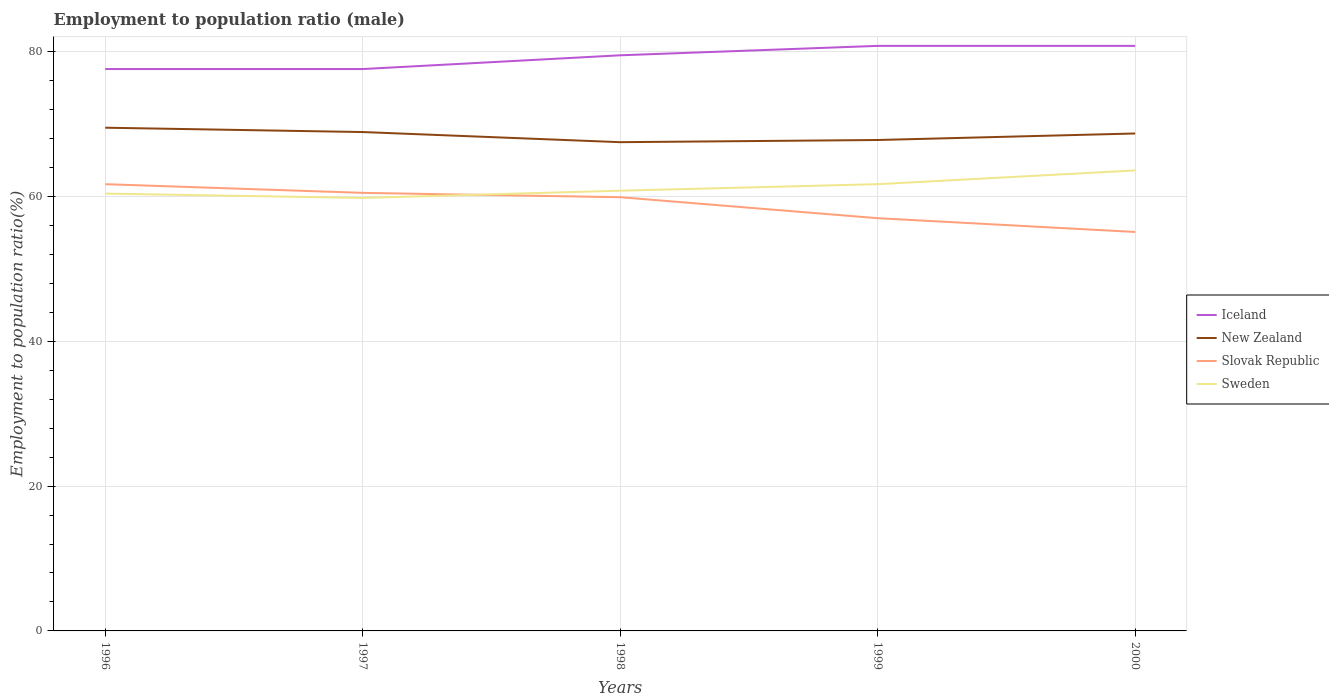Does the line corresponding to Slovak Republic intersect with the line corresponding to Sweden?
Your response must be concise. Yes. Is the number of lines equal to the number of legend labels?
Your answer should be compact. Yes. Across all years, what is the maximum employment to population ratio in Slovak Republic?
Offer a very short reply. 55.1. In which year was the employment to population ratio in Slovak Republic maximum?
Your answer should be very brief. 2000. What is the total employment to population ratio in Slovak Republic in the graph?
Provide a short and direct response. 0.6. What is the difference between the highest and the second highest employment to population ratio in Iceland?
Offer a terse response. 3.2. What is the difference between the highest and the lowest employment to population ratio in Iceland?
Offer a terse response. 3. Is the employment to population ratio in New Zealand strictly greater than the employment to population ratio in Iceland over the years?
Give a very brief answer. Yes. How many lines are there?
Provide a succinct answer. 4. How many years are there in the graph?
Offer a terse response. 5. What is the difference between two consecutive major ticks on the Y-axis?
Keep it short and to the point. 20. Does the graph contain grids?
Provide a short and direct response. Yes. Where does the legend appear in the graph?
Your answer should be very brief. Center right. How are the legend labels stacked?
Your answer should be very brief. Vertical. What is the title of the graph?
Offer a very short reply. Employment to population ratio (male). What is the Employment to population ratio(%) in Iceland in 1996?
Offer a terse response. 77.6. What is the Employment to population ratio(%) in New Zealand in 1996?
Offer a terse response. 69.5. What is the Employment to population ratio(%) in Slovak Republic in 1996?
Your answer should be very brief. 61.7. What is the Employment to population ratio(%) in Sweden in 1996?
Offer a terse response. 60.4. What is the Employment to population ratio(%) of Iceland in 1997?
Your answer should be very brief. 77.6. What is the Employment to population ratio(%) of New Zealand in 1997?
Your answer should be very brief. 68.9. What is the Employment to population ratio(%) of Slovak Republic in 1997?
Offer a very short reply. 60.5. What is the Employment to population ratio(%) in Sweden in 1997?
Ensure brevity in your answer.  59.8. What is the Employment to population ratio(%) in Iceland in 1998?
Your answer should be compact. 79.5. What is the Employment to population ratio(%) of New Zealand in 1998?
Offer a terse response. 67.5. What is the Employment to population ratio(%) of Slovak Republic in 1998?
Offer a very short reply. 59.9. What is the Employment to population ratio(%) in Sweden in 1998?
Ensure brevity in your answer.  60.8. What is the Employment to population ratio(%) of Iceland in 1999?
Your answer should be compact. 80.8. What is the Employment to population ratio(%) in New Zealand in 1999?
Keep it short and to the point. 67.8. What is the Employment to population ratio(%) of Sweden in 1999?
Provide a succinct answer. 61.7. What is the Employment to population ratio(%) of Iceland in 2000?
Your response must be concise. 80.8. What is the Employment to population ratio(%) in New Zealand in 2000?
Keep it short and to the point. 68.7. What is the Employment to population ratio(%) in Slovak Republic in 2000?
Ensure brevity in your answer.  55.1. What is the Employment to population ratio(%) of Sweden in 2000?
Keep it short and to the point. 63.6. Across all years, what is the maximum Employment to population ratio(%) in Iceland?
Provide a succinct answer. 80.8. Across all years, what is the maximum Employment to population ratio(%) in New Zealand?
Your response must be concise. 69.5. Across all years, what is the maximum Employment to population ratio(%) in Slovak Republic?
Your response must be concise. 61.7. Across all years, what is the maximum Employment to population ratio(%) of Sweden?
Your response must be concise. 63.6. Across all years, what is the minimum Employment to population ratio(%) in Iceland?
Provide a succinct answer. 77.6. Across all years, what is the minimum Employment to population ratio(%) of New Zealand?
Your answer should be very brief. 67.5. Across all years, what is the minimum Employment to population ratio(%) in Slovak Republic?
Your answer should be very brief. 55.1. Across all years, what is the minimum Employment to population ratio(%) of Sweden?
Your answer should be very brief. 59.8. What is the total Employment to population ratio(%) in Iceland in the graph?
Provide a short and direct response. 396.3. What is the total Employment to population ratio(%) of New Zealand in the graph?
Offer a very short reply. 342.4. What is the total Employment to population ratio(%) in Slovak Republic in the graph?
Your answer should be compact. 294.2. What is the total Employment to population ratio(%) of Sweden in the graph?
Offer a very short reply. 306.3. What is the difference between the Employment to population ratio(%) of Iceland in 1996 and that in 1997?
Keep it short and to the point. 0. What is the difference between the Employment to population ratio(%) of Iceland in 1996 and that in 1998?
Give a very brief answer. -1.9. What is the difference between the Employment to population ratio(%) in Slovak Republic in 1996 and that in 1998?
Your response must be concise. 1.8. What is the difference between the Employment to population ratio(%) in Iceland in 1996 and that in 1999?
Make the answer very short. -3.2. What is the difference between the Employment to population ratio(%) of Sweden in 1996 and that in 1999?
Give a very brief answer. -1.3. What is the difference between the Employment to population ratio(%) in Iceland in 1996 and that in 2000?
Your response must be concise. -3.2. What is the difference between the Employment to population ratio(%) of Sweden in 1997 and that in 1998?
Your answer should be compact. -1. What is the difference between the Employment to population ratio(%) of Iceland in 1997 and that in 1999?
Ensure brevity in your answer.  -3.2. What is the difference between the Employment to population ratio(%) in Sweden in 1997 and that in 1999?
Make the answer very short. -1.9. What is the difference between the Employment to population ratio(%) of Iceland in 1997 and that in 2000?
Give a very brief answer. -3.2. What is the difference between the Employment to population ratio(%) in New Zealand in 1997 and that in 2000?
Keep it short and to the point. 0.2. What is the difference between the Employment to population ratio(%) of Slovak Republic in 1997 and that in 2000?
Your answer should be compact. 5.4. What is the difference between the Employment to population ratio(%) of Iceland in 1998 and that in 1999?
Provide a succinct answer. -1.3. What is the difference between the Employment to population ratio(%) of New Zealand in 1998 and that in 1999?
Your answer should be very brief. -0.3. What is the difference between the Employment to population ratio(%) of Slovak Republic in 1998 and that in 1999?
Your answer should be compact. 2.9. What is the difference between the Employment to population ratio(%) of Iceland in 1998 and that in 2000?
Offer a very short reply. -1.3. What is the difference between the Employment to population ratio(%) of Iceland in 1999 and that in 2000?
Keep it short and to the point. 0. What is the difference between the Employment to population ratio(%) in New Zealand in 1999 and that in 2000?
Provide a succinct answer. -0.9. What is the difference between the Employment to population ratio(%) of Slovak Republic in 1999 and that in 2000?
Make the answer very short. 1.9. What is the difference between the Employment to population ratio(%) of Iceland in 1996 and the Employment to population ratio(%) of New Zealand in 1997?
Provide a short and direct response. 8.7. What is the difference between the Employment to population ratio(%) of New Zealand in 1996 and the Employment to population ratio(%) of Slovak Republic in 1997?
Offer a terse response. 9. What is the difference between the Employment to population ratio(%) of New Zealand in 1996 and the Employment to population ratio(%) of Sweden in 1997?
Offer a terse response. 9.7. What is the difference between the Employment to population ratio(%) in Iceland in 1996 and the Employment to population ratio(%) in Slovak Republic in 1998?
Make the answer very short. 17.7. What is the difference between the Employment to population ratio(%) in Iceland in 1996 and the Employment to population ratio(%) in Sweden in 1998?
Make the answer very short. 16.8. What is the difference between the Employment to population ratio(%) of Iceland in 1996 and the Employment to population ratio(%) of Slovak Republic in 1999?
Make the answer very short. 20.6. What is the difference between the Employment to population ratio(%) of Slovak Republic in 1996 and the Employment to population ratio(%) of Sweden in 1999?
Make the answer very short. 0. What is the difference between the Employment to population ratio(%) of New Zealand in 1996 and the Employment to population ratio(%) of Slovak Republic in 2000?
Provide a short and direct response. 14.4. What is the difference between the Employment to population ratio(%) of Slovak Republic in 1996 and the Employment to population ratio(%) of Sweden in 2000?
Provide a short and direct response. -1.9. What is the difference between the Employment to population ratio(%) of Iceland in 1997 and the Employment to population ratio(%) of Sweden in 1998?
Your answer should be compact. 16.8. What is the difference between the Employment to population ratio(%) of Iceland in 1997 and the Employment to population ratio(%) of Slovak Republic in 1999?
Give a very brief answer. 20.6. What is the difference between the Employment to population ratio(%) of New Zealand in 1997 and the Employment to population ratio(%) of Slovak Republic in 1999?
Provide a short and direct response. 11.9. What is the difference between the Employment to population ratio(%) of Slovak Republic in 1997 and the Employment to population ratio(%) of Sweden in 1999?
Make the answer very short. -1.2. What is the difference between the Employment to population ratio(%) in Iceland in 1997 and the Employment to population ratio(%) in Slovak Republic in 2000?
Ensure brevity in your answer.  22.5. What is the difference between the Employment to population ratio(%) of Iceland in 1997 and the Employment to population ratio(%) of Sweden in 2000?
Your answer should be compact. 14. What is the difference between the Employment to population ratio(%) of New Zealand in 1997 and the Employment to population ratio(%) of Sweden in 2000?
Your answer should be very brief. 5.3. What is the difference between the Employment to population ratio(%) in Slovak Republic in 1997 and the Employment to population ratio(%) in Sweden in 2000?
Your answer should be very brief. -3.1. What is the difference between the Employment to population ratio(%) of Iceland in 1998 and the Employment to population ratio(%) of Sweden in 1999?
Provide a short and direct response. 17.8. What is the difference between the Employment to population ratio(%) of New Zealand in 1998 and the Employment to population ratio(%) of Slovak Republic in 1999?
Offer a very short reply. 10.5. What is the difference between the Employment to population ratio(%) in Slovak Republic in 1998 and the Employment to population ratio(%) in Sweden in 1999?
Your answer should be compact. -1.8. What is the difference between the Employment to population ratio(%) in Iceland in 1998 and the Employment to population ratio(%) in New Zealand in 2000?
Keep it short and to the point. 10.8. What is the difference between the Employment to population ratio(%) in Iceland in 1998 and the Employment to population ratio(%) in Slovak Republic in 2000?
Give a very brief answer. 24.4. What is the difference between the Employment to population ratio(%) of Iceland in 1998 and the Employment to population ratio(%) of Sweden in 2000?
Your response must be concise. 15.9. What is the difference between the Employment to population ratio(%) of New Zealand in 1998 and the Employment to population ratio(%) of Sweden in 2000?
Make the answer very short. 3.9. What is the difference between the Employment to population ratio(%) in Slovak Republic in 1998 and the Employment to population ratio(%) in Sweden in 2000?
Offer a very short reply. -3.7. What is the difference between the Employment to population ratio(%) of Iceland in 1999 and the Employment to population ratio(%) of Slovak Republic in 2000?
Your answer should be very brief. 25.7. What is the difference between the Employment to population ratio(%) in Iceland in 1999 and the Employment to population ratio(%) in Sweden in 2000?
Your answer should be compact. 17.2. What is the average Employment to population ratio(%) of Iceland per year?
Offer a terse response. 79.26. What is the average Employment to population ratio(%) of New Zealand per year?
Provide a succinct answer. 68.48. What is the average Employment to population ratio(%) of Slovak Republic per year?
Provide a short and direct response. 58.84. What is the average Employment to population ratio(%) in Sweden per year?
Give a very brief answer. 61.26. In the year 1996, what is the difference between the Employment to population ratio(%) in New Zealand and Employment to population ratio(%) in Slovak Republic?
Make the answer very short. 7.8. In the year 1996, what is the difference between the Employment to population ratio(%) of New Zealand and Employment to population ratio(%) of Sweden?
Your response must be concise. 9.1. In the year 1996, what is the difference between the Employment to population ratio(%) in Slovak Republic and Employment to population ratio(%) in Sweden?
Your answer should be compact. 1.3. In the year 1997, what is the difference between the Employment to population ratio(%) in Iceland and Employment to population ratio(%) in Slovak Republic?
Your answer should be very brief. 17.1. In the year 1997, what is the difference between the Employment to population ratio(%) in New Zealand and Employment to population ratio(%) in Sweden?
Ensure brevity in your answer.  9.1. In the year 1998, what is the difference between the Employment to population ratio(%) in Iceland and Employment to population ratio(%) in New Zealand?
Provide a short and direct response. 12. In the year 1998, what is the difference between the Employment to population ratio(%) of Iceland and Employment to population ratio(%) of Slovak Republic?
Your answer should be compact. 19.6. In the year 1998, what is the difference between the Employment to population ratio(%) in Iceland and Employment to population ratio(%) in Sweden?
Your response must be concise. 18.7. In the year 1998, what is the difference between the Employment to population ratio(%) in New Zealand and Employment to population ratio(%) in Sweden?
Make the answer very short. 6.7. In the year 1998, what is the difference between the Employment to population ratio(%) in Slovak Republic and Employment to population ratio(%) in Sweden?
Offer a very short reply. -0.9. In the year 1999, what is the difference between the Employment to population ratio(%) of Iceland and Employment to population ratio(%) of New Zealand?
Provide a short and direct response. 13. In the year 1999, what is the difference between the Employment to population ratio(%) in Iceland and Employment to population ratio(%) in Slovak Republic?
Your answer should be very brief. 23.8. In the year 1999, what is the difference between the Employment to population ratio(%) of Iceland and Employment to population ratio(%) of Sweden?
Offer a terse response. 19.1. In the year 1999, what is the difference between the Employment to population ratio(%) of New Zealand and Employment to population ratio(%) of Slovak Republic?
Offer a very short reply. 10.8. In the year 1999, what is the difference between the Employment to population ratio(%) in Slovak Republic and Employment to population ratio(%) in Sweden?
Give a very brief answer. -4.7. In the year 2000, what is the difference between the Employment to population ratio(%) in Iceland and Employment to population ratio(%) in New Zealand?
Keep it short and to the point. 12.1. In the year 2000, what is the difference between the Employment to population ratio(%) of Iceland and Employment to population ratio(%) of Slovak Republic?
Offer a very short reply. 25.7. In the year 2000, what is the difference between the Employment to population ratio(%) of Iceland and Employment to population ratio(%) of Sweden?
Keep it short and to the point. 17.2. In the year 2000, what is the difference between the Employment to population ratio(%) in New Zealand and Employment to population ratio(%) in Sweden?
Offer a terse response. 5.1. In the year 2000, what is the difference between the Employment to population ratio(%) in Slovak Republic and Employment to population ratio(%) in Sweden?
Your answer should be compact. -8.5. What is the ratio of the Employment to population ratio(%) of Iceland in 1996 to that in 1997?
Your response must be concise. 1. What is the ratio of the Employment to population ratio(%) of New Zealand in 1996 to that in 1997?
Your answer should be compact. 1.01. What is the ratio of the Employment to population ratio(%) of Slovak Republic in 1996 to that in 1997?
Make the answer very short. 1.02. What is the ratio of the Employment to population ratio(%) in Iceland in 1996 to that in 1998?
Your response must be concise. 0.98. What is the ratio of the Employment to population ratio(%) in New Zealand in 1996 to that in 1998?
Your answer should be compact. 1.03. What is the ratio of the Employment to population ratio(%) of Slovak Republic in 1996 to that in 1998?
Offer a very short reply. 1.03. What is the ratio of the Employment to population ratio(%) in Sweden in 1996 to that in 1998?
Provide a succinct answer. 0.99. What is the ratio of the Employment to population ratio(%) in Iceland in 1996 to that in 1999?
Give a very brief answer. 0.96. What is the ratio of the Employment to population ratio(%) of New Zealand in 1996 to that in 1999?
Ensure brevity in your answer.  1.03. What is the ratio of the Employment to population ratio(%) in Slovak Republic in 1996 to that in 1999?
Offer a very short reply. 1.08. What is the ratio of the Employment to population ratio(%) of Sweden in 1996 to that in 1999?
Keep it short and to the point. 0.98. What is the ratio of the Employment to population ratio(%) in Iceland in 1996 to that in 2000?
Keep it short and to the point. 0.96. What is the ratio of the Employment to population ratio(%) in New Zealand in 1996 to that in 2000?
Provide a short and direct response. 1.01. What is the ratio of the Employment to population ratio(%) of Slovak Republic in 1996 to that in 2000?
Your answer should be compact. 1.12. What is the ratio of the Employment to population ratio(%) of Sweden in 1996 to that in 2000?
Your response must be concise. 0.95. What is the ratio of the Employment to population ratio(%) of Iceland in 1997 to that in 1998?
Make the answer very short. 0.98. What is the ratio of the Employment to population ratio(%) in New Zealand in 1997 to that in 1998?
Ensure brevity in your answer.  1.02. What is the ratio of the Employment to population ratio(%) of Sweden in 1997 to that in 1998?
Provide a succinct answer. 0.98. What is the ratio of the Employment to population ratio(%) of Iceland in 1997 to that in 1999?
Give a very brief answer. 0.96. What is the ratio of the Employment to population ratio(%) of New Zealand in 1997 to that in 1999?
Offer a very short reply. 1.02. What is the ratio of the Employment to population ratio(%) in Slovak Republic in 1997 to that in 1999?
Ensure brevity in your answer.  1.06. What is the ratio of the Employment to population ratio(%) in Sweden in 1997 to that in 1999?
Your response must be concise. 0.97. What is the ratio of the Employment to population ratio(%) of Iceland in 1997 to that in 2000?
Offer a very short reply. 0.96. What is the ratio of the Employment to population ratio(%) in New Zealand in 1997 to that in 2000?
Give a very brief answer. 1. What is the ratio of the Employment to population ratio(%) of Slovak Republic in 1997 to that in 2000?
Offer a terse response. 1.1. What is the ratio of the Employment to population ratio(%) in Sweden in 1997 to that in 2000?
Make the answer very short. 0.94. What is the ratio of the Employment to population ratio(%) of Iceland in 1998 to that in 1999?
Give a very brief answer. 0.98. What is the ratio of the Employment to population ratio(%) in New Zealand in 1998 to that in 1999?
Your answer should be very brief. 1. What is the ratio of the Employment to population ratio(%) in Slovak Republic in 1998 to that in 1999?
Your response must be concise. 1.05. What is the ratio of the Employment to population ratio(%) in Sweden in 1998 to that in 1999?
Keep it short and to the point. 0.99. What is the ratio of the Employment to population ratio(%) in Iceland in 1998 to that in 2000?
Provide a succinct answer. 0.98. What is the ratio of the Employment to population ratio(%) of New Zealand in 1998 to that in 2000?
Ensure brevity in your answer.  0.98. What is the ratio of the Employment to population ratio(%) of Slovak Republic in 1998 to that in 2000?
Give a very brief answer. 1.09. What is the ratio of the Employment to population ratio(%) in Sweden in 1998 to that in 2000?
Your response must be concise. 0.96. What is the ratio of the Employment to population ratio(%) in New Zealand in 1999 to that in 2000?
Keep it short and to the point. 0.99. What is the ratio of the Employment to population ratio(%) in Slovak Republic in 1999 to that in 2000?
Provide a short and direct response. 1.03. What is the ratio of the Employment to population ratio(%) of Sweden in 1999 to that in 2000?
Provide a short and direct response. 0.97. What is the difference between the highest and the second highest Employment to population ratio(%) of Iceland?
Offer a terse response. 0. What is the difference between the highest and the second highest Employment to population ratio(%) in New Zealand?
Your response must be concise. 0.6. What is the difference between the highest and the second highest Employment to population ratio(%) in Sweden?
Ensure brevity in your answer.  1.9. What is the difference between the highest and the lowest Employment to population ratio(%) of Iceland?
Provide a short and direct response. 3.2. What is the difference between the highest and the lowest Employment to population ratio(%) of Sweden?
Your response must be concise. 3.8. 